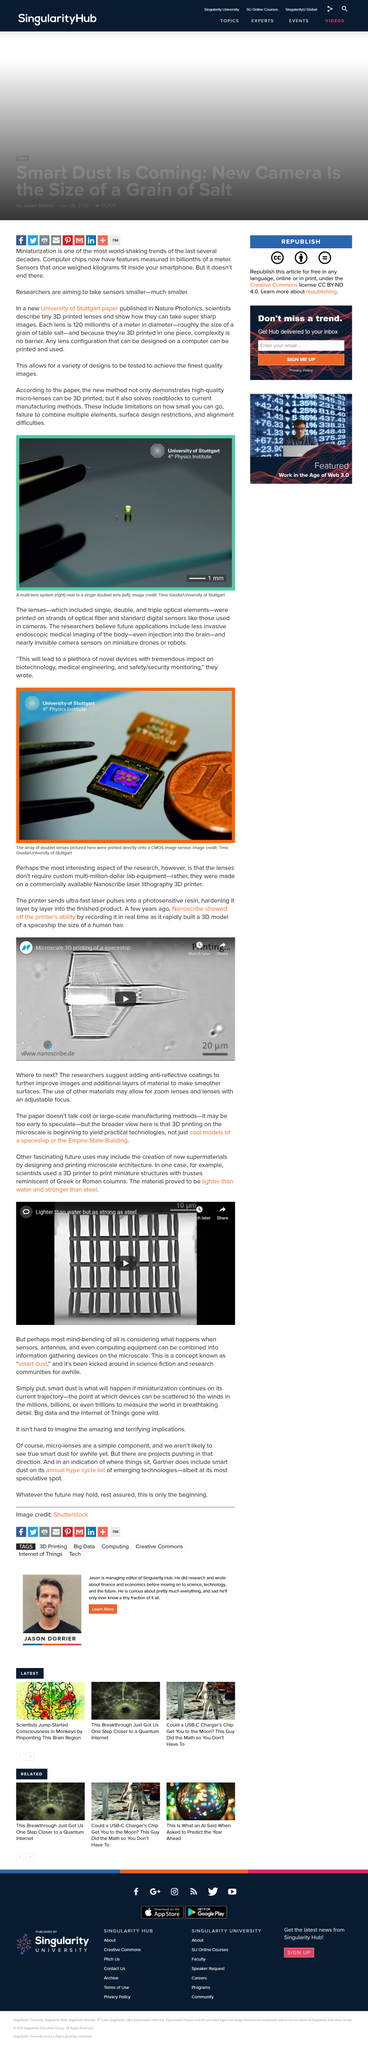Outline some significant characteristics in this image. The term "smart dust" has been discussed in both science fiction and research communities. I declare that something exists that is lighter than water but as strong as steel, which is known as 'Smart Dust'. It is highly unlikely that true smart dust will be seen in the near future. The scale of the photograph is 1mm. The photograph was taken by Timo Gissibi. 